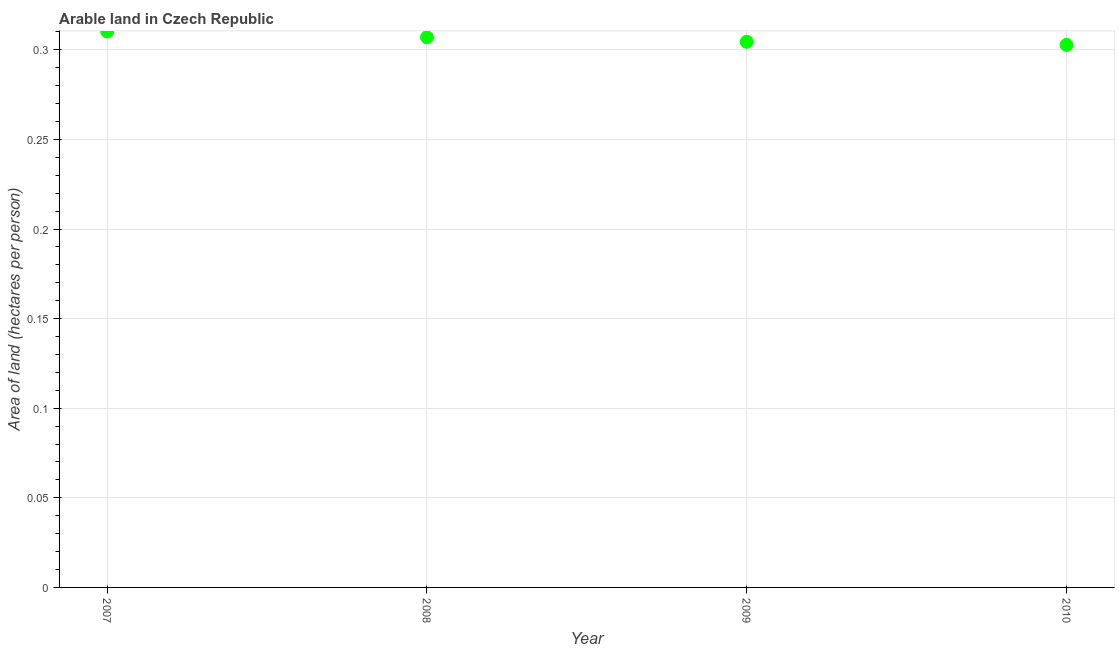What is the area of arable land in 2007?
Provide a short and direct response. 0.31. Across all years, what is the maximum area of arable land?
Keep it short and to the point. 0.31. Across all years, what is the minimum area of arable land?
Offer a terse response. 0.3. In which year was the area of arable land minimum?
Your answer should be compact. 2010. What is the sum of the area of arable land?
Provide a succinct answer. 1.22. What is the difference between the area of arable land in 2007 and 2009?
Your answer should be very brief. 0.01. What is the average area of arable land per year?
Give a very brief answer. 0.31. What is the median area of arable land?
Provide a succinct answer. 0.31. In how many years, is the area of arable land greater than 0.04 hectares per person?
Your answer should be very brief. 4. What is the ratio of the area of arable land in 2008 to that in 2009?
Provide a short and direct response. 1.01. Is the difference between the area of arable land in 2007 and 2009 greater than the difference between any two years?
Provide a short and direct response. No. What is the difference between the highest and the second highest area of arable land?
Your answer should be compact. 0. What is the difference between the highest and the lowest area of arable land?
Offer a terse response. 0.01. In how many years, is the area of arable land greater than the average area of arable land taken over all years?
Ensure brevity in your answer.  2. Does the area of arable land monotonically increase over the years?
Ensure brevity in your answer.  No. How many years are there in the graph?
Make the answer very short. 4. Does the graph contain any zero values?
Provide a succinct answer. No. Does the graph contain grids?
Provide a short and direct response. Yes. What is the title of the graph?
Give a very brief answer. Arable land in Czech Republic. What is the label or title of the X-axis?
Your response must be concise. Year. What is the label or title of the Y-axis?
Provide a succinct answer. Area of land (hectares per person). What is the Area of land (hectares per person) in 2007?
Offer a terse response. 0.31. What is the Area of land (hectares per person) in 2008?
Your answer should be compact. 0.31. What is the Area of land (hectares per person) in 2009?
Your answer should be very brief. 0.3. What is the Area of land (hectares per person) in 2010?
Your response must be concise. 0.3. What is the difference between the Area of land (hectares per person) in 2007 and 2008?
Make the answer very short. 0. What is the difference between the Area of land (hectares per person) in 2007 and 2009?
Ensure brevity in your answer.  0.01. What is the difference between the Area of land (hectares per person) in 2007 and 2010?
Your response must be concise. 0.01. What is the difference between the Area of land (hectares per person) in 2008 and 2009?
Provide a succinct answer. 0. What is the difference between the Area of land (hectares per person) in 2008 and 2010?
Make the answer very short. 0. What is the difference between the Area of land (hectares per person) in 2009 and 2010?
Offer a very short reply. 0. What is the ratio of the Area of land (hectares per person) in 2007 to that in 2009?
Your answer should be compact. 1.02. What is the ratio of the Area of land (hectares per person) in 2007 to that in 2010?
Keep it short and to the point. 1.02. What is the ratio of the Area of land (hectares per person) in 2009 to that in 2010?
Offer a terse response. 1.01. 